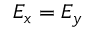Convert formula to latex. <formula><loc_0><loc_0><loc_500><loc_500>E _ { x } = E _ { y }</formula> 